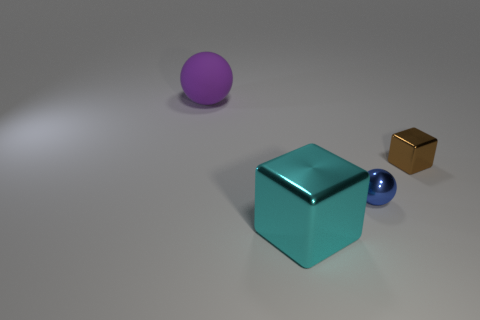Subtract 2 cubes. How many cubes are left? 0 Add 1 purple balls. How many objects exist? 5 Subtract all blue blocks. Subtract all gray spheres. How many blocks are left? 2 Subtract all red blocks. How many brown balls are left? 0 Subtract all large balls. Subtract all tiny red balls. How many objects are left? 3 Add 1 large purple matte spheres. How many large purple matte spheres are left? 2 Add 2 big blocks. How many big blocks exist? 3 Subtract 0 blue cylinders. How many objects are left? 4 